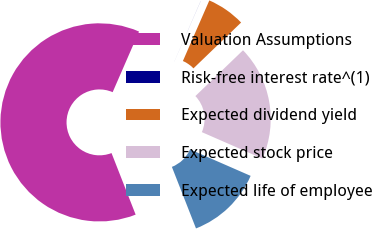<chart> <loc_0><loc_0><loc_500><loc_500><pie_chart><fcel>Valuation Assumptions<fcel>Risk-free interest rate^(1)<fcel>Expected dividend yield<fcel>Expected stock price<fcel>Expected life of employee<nl><fcel>62.48%<fcel>0.01%<fcel>6.26%<fcel>18.75%<fcel>12.5%<nl></chart> 